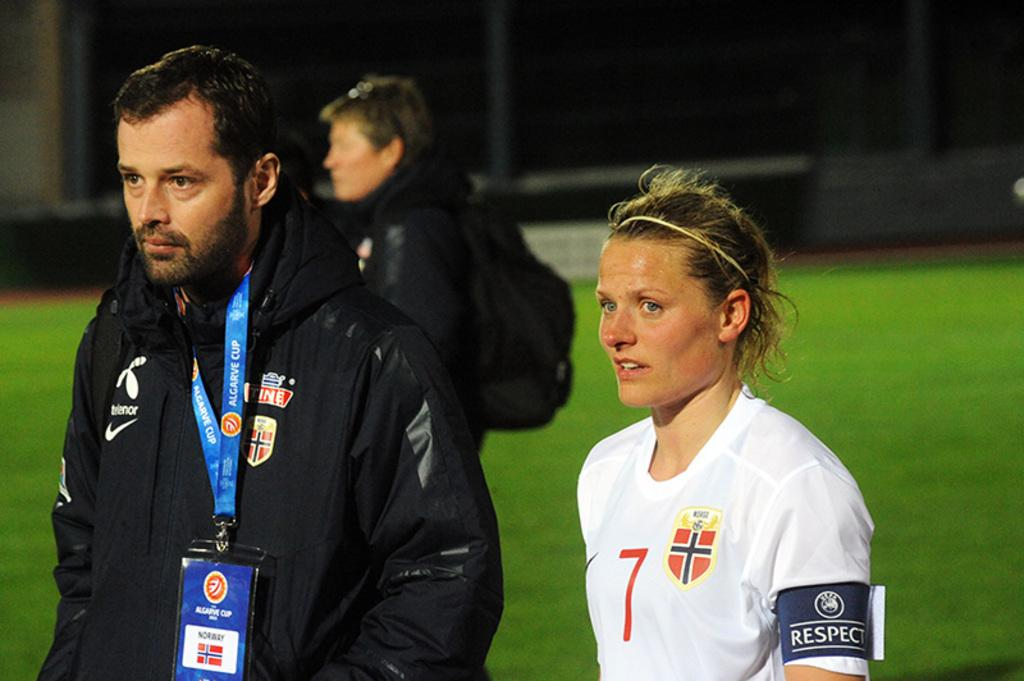Provide a one-sentence caption for the provided image. a person that has the number 7 on their soccer jersey outside. 